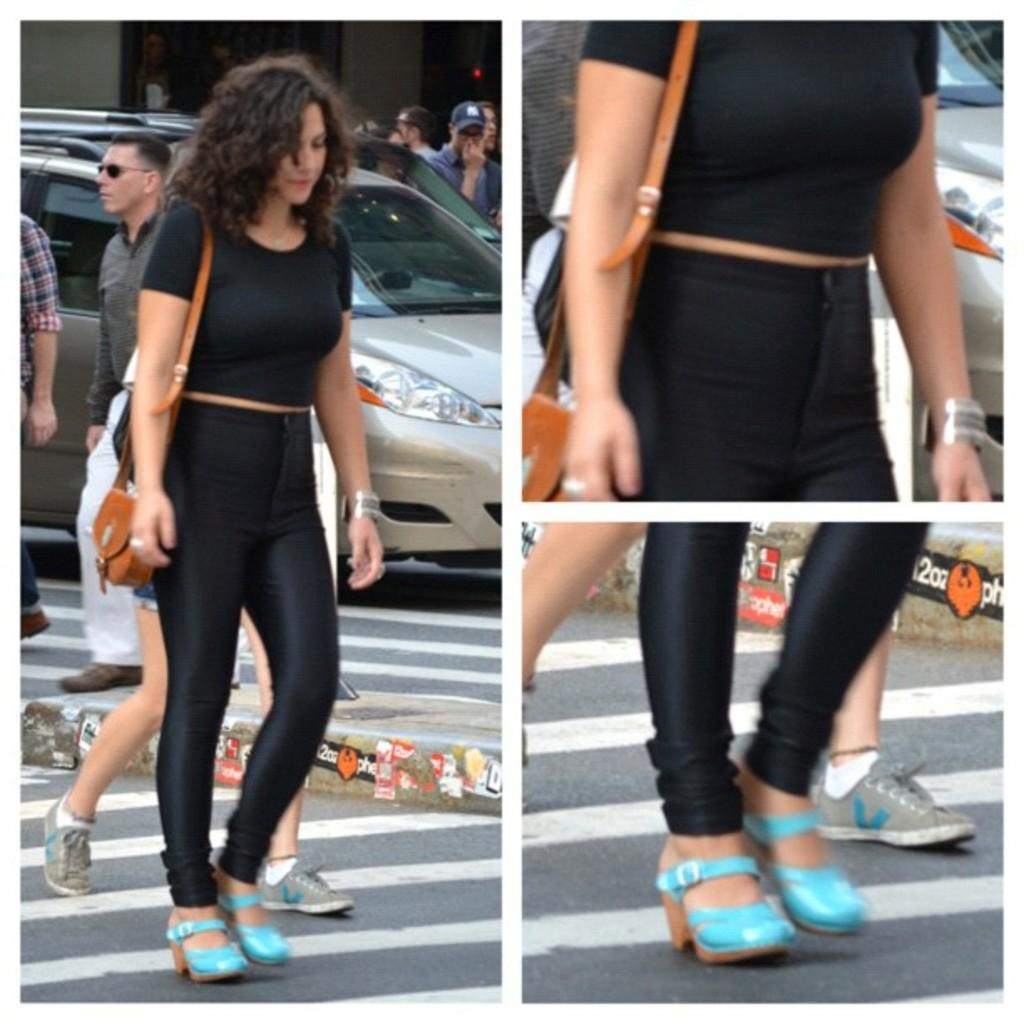What type of artwork is depicted in the image? The image is a collage of images. What subjects are included in the collage? There are people and a car in the collage. What type of mask is being worn by the person in the image? There is no person wearing a mask in the image, as it is a collage of images and not a single photograph or illustration. 